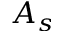Convert formula to latex. <formula><loc_0><loc_0><loc_500><loc_500>A _ { s }</formula> 